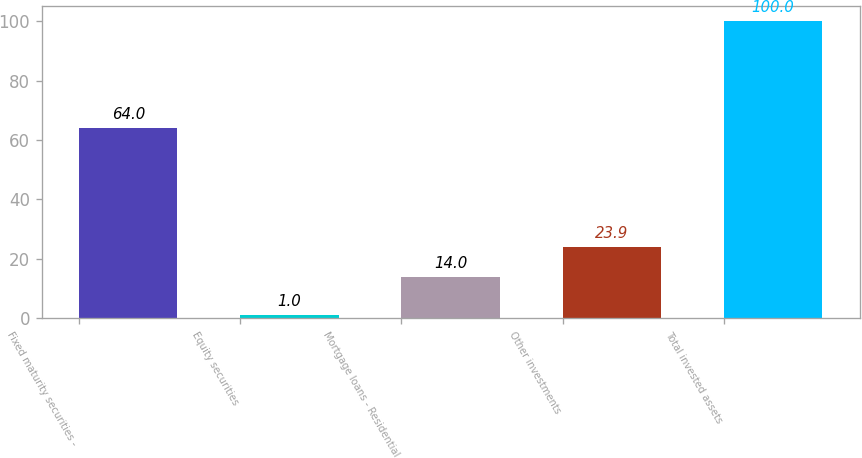<chart> <loc_0><loc_0><loc_500><loc_500><bar_chart><fcel>Fixed maturity securities -<fcel>Equity securities<fcel>Mortgage loans - Residential<fcel>Other investments<fcel>Total invested assets<nl><fcel>64<fcel>1<fcel>14<fcel>23.9<fcel>100<nl></chart> 